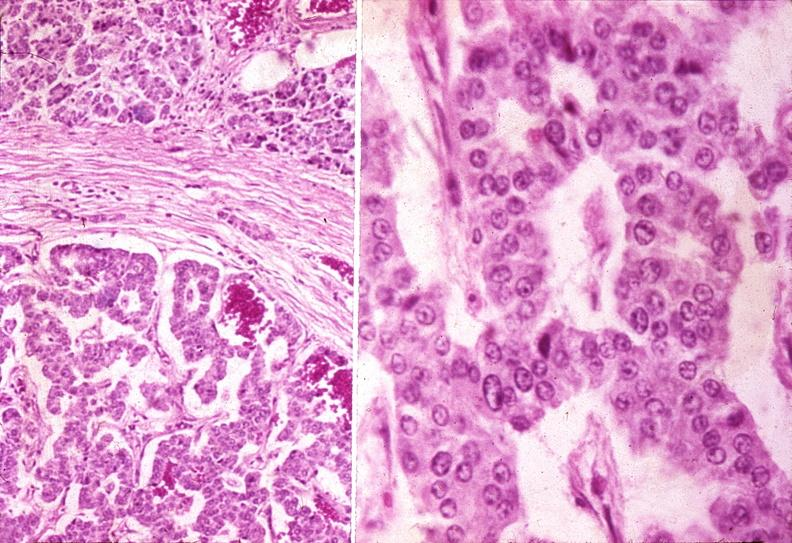what does this image show?
Answer the question using a single word or phrase. Islet cell carcinoma 